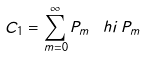Convert formula to latex. <formula><loc_0><loc_0><loc_500><loc_500>C _ { 1 } = \sum _ { m = 0 } ^ { \infty } P _ { m } \, \ h i \, P _ { m }</formula> 